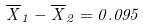<formula> <loc_0><loc_0><loc_500><loc_500>\overline { X } _ { 1 } - \overline { X } _ { 2 } = 0 . 0 9 5</formula> 